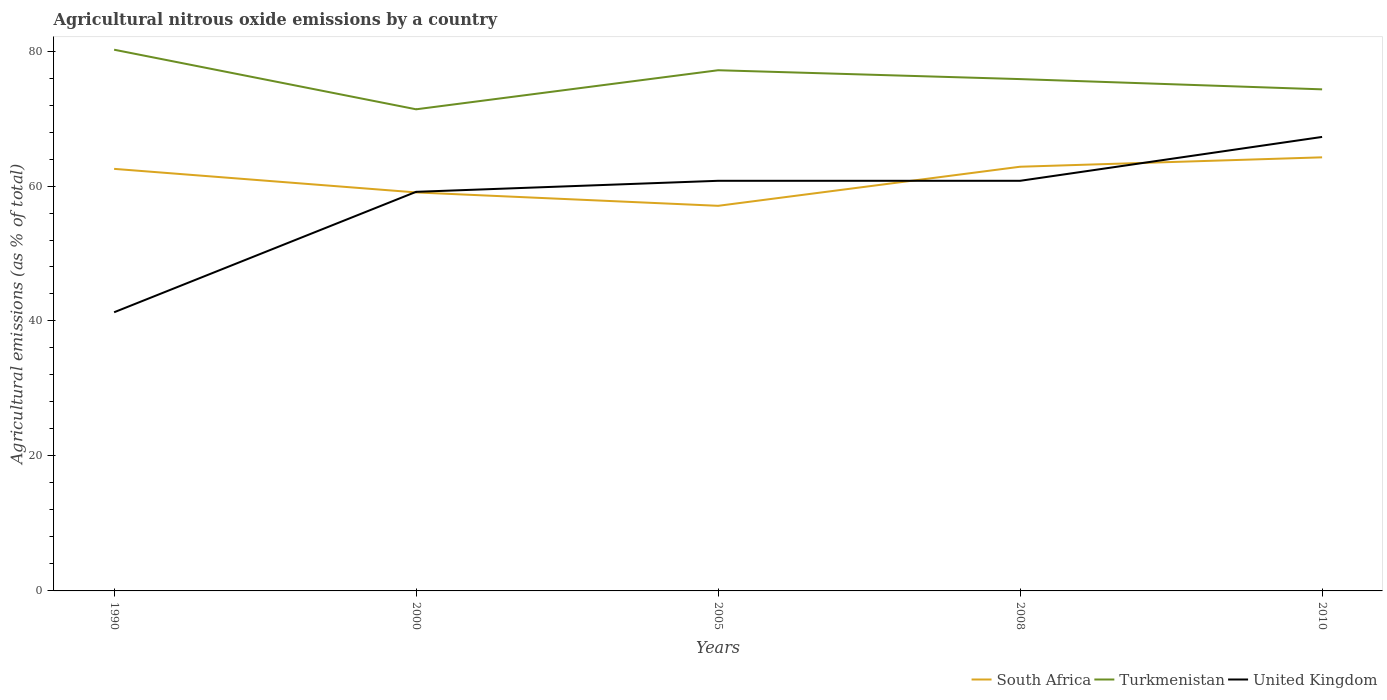Is the number of lines equal to the number of legend labels?
Provide a short and direct response. Yes. Across all years, what is the maximum amount of agricultural nitrous oxide emitted in Turkmenistan?
Offer a very short reply. 71.37. In which year was the amount of agricultural nitrous oxide emitted in South Africa maximum?
Provide a succinct answer. 2005. What is the total amount of agricultural nitrous oxide emitted in South Africa in the graph?
Your answer should be very brief. 1.98. What is the difference between the highest and the second highest amount of agricultural nitrous oxide emitted in United Kingdom?
Keep it short and to the point. 25.98. How many years are there in the graph?
Your response must be concise. 5. Where does the legend appear in the graph?
Give a very brief answer. Bottom right. What is the title of the graph?
Ensure brevity in your answer.  Agricultural nitrous oxide emissions by a country. What is the label or title of the X-axis?
Ensure brevity in your answer.  Years. What is the label or title of the Y-axis?
Ensure brevity in your answer.  Agricultural emissions (as % of total). What is the Agricultural emissions (as % of total) in South Africa in 1990?
Offer a very short reply. 62.54. What is the Agricultural emissions (as % of total) in Turkmenistan in 1990?
Your answer should be compact. 80.2. What is the Agricultural emissions (as % of total) in United Kingdom in 1990?
Your answer should be very brief. 41.29. What is the Agricultural emissions (as % of total) in South Africa in 2000?
Give a very brief answer. 59.05. What is the Agricultural emissions (as % of total) of Turkmenistan in 2000?
Your response must be concise. 71.37. What is the Agricultural emissions (as % of total) of United Kingdom in 2000?
Make the answer very short. 59.14. What is the Agricultural emissions (as % of total) in South Africa in 2005?
Keep it short and to the point. 57.07. What is the Agricultural emissions (as % of total) of Turkmenistan in 2005?
Give a very brief answer. 77.16. What is the Agricultural emissions (as % of total) of United Kingdom in 2005?
Your response must be concise. 60.77. What is the Agricultural emissions (as % of total) in South Africa in 2008?
Offer a very short reply. 62.86. What is the Agricultural emissions (as % of total) in Turkmenistan in 2008?
Provide a succinct answer. 75.84. What is the Agricultural emissions (as % of total) of United Kingdom in 2008?
Your answer should be very brief. 60.77. What is the Agricultural emissions (as % of total) in South Africa in 2010?
Offer a terse response. 64.25. What is the Agricultural emissions (as % of total) in Turkmenistan in 2010?
Offer a terse response. 74.32. What is the Agricultural emissions (as % of total) in United Kingdom in 2010?
Give a very brief answer. 67.27. Across all years, what is the maximum Agricultural emissions (as % of total) of South Africa?
Your response must be concise. 64.25. Across all years, what is the maximum Agricultural emissions (as % of total) in Turkmenistan?
Make the answer very short. 80.2. Across all years, what is the maximum Agricultural emissions (as % of total) of United Kingdom?
Make the answer very short. 67.27. Across all years, what is the minimum Agricultural emissions (as % of total) of South Africa?
Make the answer very short. 57.07. Across all years, what is the minimum Agricultural emissions (as % of total) in Turkmenistan?
Your response must be concise. 71.37. Across all years, what is the minimum Agricultural emissions (as % of total) in United Kingdom?
Make the answer very short. 41.29. What is the total Agricultural emissions (as % of total) of South Africa in the graph?
Give a very brief answer. 305.76. What is the total Agricultural emissions (as % of total) of Turkmenistan in the graph?
Provide a succinct answer. 378.89. What is the total Agricultural emissions (as % of total) in United Kingdom in the graph?
Provide a short and direct response. 289.25. What is the difference between the Agricultural emissions (as % of total) in South Africa in 1990 and that in 2000?
Your response must be concise. 3.49. What is the difference between the Agricultural emissions (as % of total) in Turkmenistan in 1990 and that in 2000?
Your answer should be compact. 8.83. What is the difference between the Agricultural emissions (as % of total) in United Kingdom in 1990 and that in 2000?
Offer a very short reply. -17.85. What is the difference between the Agricultural emissions (as % of total) of South Africa in 1990 and that in 2005?
Your answer should be compact. 5.48. What is the difference between the Agricultural emissions (as % of total) in Turkmenistan in 1990 and that in 2005?
Keep it short and to the point. 3.04. What is the difference between the Agricultural emissions (as % of total) of United Kingdom in 1990 and that in 2005?
Your answer should be very brief. -19.48. What is the difference between the Agricultural emissions (as % of total) of South Africa in 1990 and that in 2008?
Keep it short and to the point. -0.32. What is the difference between the Agricultural emissions (as % of total) of Turkmenistan in 1990 and that in 2008?
Offer a terse response. 4.36. What is the difference between the Agricultural emissions (as % of total) of United Kingdom in 1990 and that in 2008?
Provide a succinct answer. -19.48. What is the difference between the Agricultural emissions (as % of total) in South Africa in 1990 and that in 2010?
Offer a very short reply. -1.71. What is the difference between the Agricultural emissions (as % of total) of Turkmenistan in 1990 and that in 2010?
Offer a very short reply. 5.87. What is the difference between the Agricultural emissions (as % of total) in United Kingdom in 1990 and that in 2010?
Your answer should be compact. -25.98. What is the difference between the Agricultural emissions (as % of total) in South Africa in 2000 and that in 2005?
Offer a terse response. 1.98. What is the difference between the Agricultural emissions (as % of total) of Turkmenistan in 2000 and that in 2005?
Your answer should be compact. -5.79. What is the difference between the Agricultural emissions (as % of total) in United Kingdom in 2000 and that in 2005?
Offer a very short reply. -1.63. What is the difference between the Agricultural emissions (as % of total) in South Africa in 2000 and that in 2008?
Your response must be concise. -3.81. What is the difference between the Agricultural emissions (as % of total) of Turkmenistan in 2000 and that in 2008?
Provide a succinct answer. -4.48. What is the difference between the Agricultural emissions (as % of total) in United Kingdom in 2000 and that in 2008?
Your answer should be compact. -1.63. What is the difference between the Agricultural emissions (as % of total) in South Africa in 2000 and that in 2010?
Your response must be concise. -5.2. What is the difference between the Agricultural emissions (as % of total) of Turkmenistan in 2000 and that in 2010?
Provide a short and direct response. -2.96. What is the difference between the Agricultural emissions (as % of total) of United Kingdom in 2000 and that in 2010?
Give a very brief answer. -8.13. What is the difference between the Agricultural emissions (as % of total) of South Africa in 2005 and that in 2008?
Offer a very short reply. -5.79. What is the difference between the Agricultural emissions (as % of total) in Turkmenistan in 2005 and that in 2008?
Your response must be concise. 1.31. What is the difference between the Agricultural emissions (as % of total) of United Kingdom in 2005 and that in 2008?
Give a very brief answer. 0. What is the difference between the Agricultural emissions (as % of total) of South Africa in 2005 and that in 2010?
Ensure brevity in your answer.  -7.18. What is the difference between the Agricultural emissions (as % of total) of Turkmenistan in 2005 and that in 2010?
Provide a short and direct response. 2.83. What is the difference between the Agricultural emissions (as % of total) of United Kingdom in 2005 and that in 2010?
Your answer should be compact. -6.5. What is the difference between the Agricultural emissions (as % of total) of South Africa in 2008 and that in 2010?
Give a very brief answer. -1.39. What is the difference between the Agricultural emissions (as % of total) of Turkmenistan in 2008 and that in 2010?
Keep it short and to the point. 1.52. What is the difference between the Agricultural emissions (as % of total) of United Kingdom in 2008 and that in 2010?
Your answer should be compact. -6.5. What is the difference between the Agricultural emissions (as % of total) in South Africa in 1990 and the Agricultural emissions (as % of total) in Turkmenistan in 2000?
Ensure brevity in your answer.  -8.83. What is the difference between the Agricultural emissions (as % of total) of South Africa in 1990 and the Agricultural emissions (as % of total) of United Kingdom in 2000?
Provide a succinct answer. 3.4. What is the difference between the Agricultural emissions (as % of total) in Turkmenistan in 1990 and the Agricultural emissions (as % of total) in United Kingdom in 2000?
Offer a terse response. 21.06. What is the difference between the Agricultural emissions (as % of total) of South Africa in 1990 and the Agricultural emissions (as % of total) of Turkmenistan in 2005?
Provide a short and direct response. -14.61. What is the difference between the Agricultural emissions (as % of total) in South Africa in 1990 and the Agricultural emissions (as % of total) in United Kingdom in 2005?
Keep it short and to the point. 1.77. What is the difference between the Agricultural emissions (as % of total) of Turkmenistan in 1990 and the Agricultural emissions (as % of total) of United Kingdom in 2005?
Your response must be concise. 19.43. What is the difference between the Agricultural emissions (as % of total) of South Africa in 1990 and the Agricultural emissions (as % of total) of Turkmenistan in 2008?
Your response must be concise. -13.3. What is the difference between the Agricultural emissions (as % of total) of South Africa in 1990 and the Agricultural emissions (as % of total) of United Kingdom in 2008?
Ensure brevity in your answer.  1.77. What is the difference between the Agricultural emissions (as % of total) of Turkmenistan in 1990 and the Agricultural emissions (as % of total) of United Kingdom in 2008?
Your answer should be compact. 19.43. What is the difference between the Agricultural emissions (as % of total) of South Africa in 1990 and the Agricultural emissions (as % of total) of Turkmenistan in 2010?
Ensure brevity in your answer.  -11.78. What is the difference between the Agricultural emissions (as % of total) in South Africa in 1990 and the Agricultural emissions (as % of total) in United Kingdom in 2010?
Provide a succinct answer. -4.73. What is the difference between the Agricultural emissions (as % of total) in Turkmenistan in 1990 and the Agricultural emissions (as % of total) in United Kingdom in 2010?
Provide a short and direct response. 12.93. What is the difference between the Agricultural emissions (as % of total) in South Africa in 2000 and the Agricultural emissions (as % of total) in Turkmenistan in 2005?
Your answer should be compact. -18.11. What is the difference between the Agricultural emissions (as % of total) of South Africa in 2000 and the Agricultural emissions (as % of total) of United Kingdom in 2005?
Keep it short and to the point. -1.72. What is the difference between the Agricultural emissions (as % of total) in Turkmenistan in 2000 and the Agricultural emissions (as % of total) in United Kingdom in 2005?
Provide a succinct answer. 10.59. What is the difference between the Agricultural emissions (as % of total) of South Africa in 2000 and the Agricultural emissions (as % of total) of Turkmenistan in 2008?
Your response must be concise. -16.79. What is the difference between the Agricultural emissions (as % of total) of South Africa in 2000 and the Agricultural emissions (as % of total) of United Kingdom in 2008?
Ensure brevity in your answer.  -1.72. What is the difference between the Agricultural emissions (as % of total) of Turkmenistan in 2000 and the Agricultural emissions (as % of total) of United Kingdom in 2008?
Make the answer very short. 10.6. What is the difference between the Agricultural emissions (as % of total) of South Africa in 2000 and the Agricultural emissions (as % of total) of Turkmenistan in 2010?
Make the answer very short. -15.27. What is the difference between the Agricultural emissions (as % of total) in South Africa in 2000 and the Agricultural emissions (as % of total) in United Kingdom in 2010?
Provide a short and direct response. -8.22. What is the difference between the Agricultural emissions (as % of total) of Turkmenistan in 2000 and the Agricultural emissions (as % of total) of United Kingdom in 2010?
Keep it short and to the point. 4.1. What is the difference between the Agricultural emissions (as % of total) in South Africa in 2005 and the Agricultural emissions (as % of total) in Turkmenistan in 2008?
Make the answer very short. -18.78. What is the difference between the Agricultural emissions (as % of total) of South Africa in 2005 and the Agricultural emissions (as % of total) of United Kingdom in 2008?
Your answer should be compact. -3.71. What is the difference between the Agricultural emissions (as % of total) in Turkmenistan in 2005 and the Agricultural emissions (as % of total) in United Kingdom in 2008?
Keep it short and to the point. 16.38. What is the difference between the Agricultural emissions (as % of total) in South Africa in 2005 and the Agricultural emissions (as % of total) in Turkmenistan in 2010?
Provide a succinct answer. -17.26. What is the difference between the Agricultural emissions (as % of total) in South Africa in 2005 and the Agricultural emissions (as % of total) in United Kingdom in 2010?
Make the answer very short. -10.21. What is the difference between the Agricultural emissions (as % of total) in Turkmenistan in 2005 and the Agricultural emissions (as % of total) in United Kingdom in 2010?
Make the answer very short. 9.88. What is the difference between the Agricultural emissions (as % of total) of South Africa in 2008 and the Agricultural emissions (as % of total) of Turkmenistan in 2010?
Offer a very short reply. -11.47. What is the difference between the Agricultural emissions (as % of total) in South Africa in 2008 and the Agricultural emissions (as % of total) in United Kingdom in 2010?
Offer a terse response. -4.42. What is the difference between the Agricultural emissions (as % of total) in Turkmenistan in 2008 and the Agricultural emissions (as % of total) in United Kingdom in 2010?
Make the answer very short. 8.57. What is the average Agricultural emissions (as % of total) in South Africa per year?
Give a very brief answer. 61.15. What is the average Agricultural emissions (as % of total) of Turkmenistan per year?
Your response must be concise. 75.78. What is the average Agricultural emissions (as % of total) in United Kingdom per year?
Offer a terse response. 57.85. In the year 1990, what is the difference between the Agricultural emissions (as % of total) of South Africa and Agricultural emissions (as % of total) of Turkmenistan?
Offer a terse response. -17.66. In the year 1990, what is the difference between the Agricultural emissions (as % of total) in South Africa and Agricultural emissions (as % of total) in United Kingdom?
Keep it short and to the point. 21.25. In the year 1990, what is the difference between the Agricultural emissions (as % of total) of Turkmenistan and Agricultural emissions (as % of total) of United Kingdom?
Your answer should be compact. 38.91. In the year 2000, what is the difference between the Agricultural emissions (as % of total) in South Africa and Agricultural emissions (as % of total) in Turkmenistan?
Provide a succinct answer. -12.32. In the year 2000, what is the difference between the Agricultural emissions (as % of total) in South Africa and Agricultural emissions (as % of total) in United Kingdom?
Offer a very short reply. -0.09. In the year 2000, what is the difference between the Agricultural emissions (as % of total) in Turkmenistan and Agricultural emissions (as % of total) in United Kingdom?
Offer a very short reply. 12.23. In the year 2005, what is the difference between the Agricultural emissions (as % of total) of South Africa and Agricultural emissions (as % of total) of Turkmenistan?
Provide a succinct answer. -20.09. In the year 2005, what is the difference between the Agricultural emissions (as % of total) in South Africa and Agricultural emissions (as % of total) in United Kingdom?
Your answer should be compact. -3.71. In the year 2005, what is the difference between the Agricultural emissions (as % of total) in Turkmenistan and Agricultural emissions (as % of total) in United Kingdom?
Keep it short and to the point. 16.38. In the year 2008, what is the difference between the Agricultural emissions (as % of total) in South Africa and Agricultural emissions (as % of total) in Turkmenistan?
Keep it short and to the point. -12.99. In the year 2008, what is the difference between the Agricultural emissions (as % of total) of South Africa and Agricultural emissions (as % of total) of United Kingdom?
Keep it short and to the point. 2.09. In the year 2008, what is the difference between the Agricultural emissions (as % of total) of Turkmenistan and Agricultural emissions (as % of total) of United Kingdom?
Keep it short and to the point. 15.07. In the year 2010, what is the difference between the Agricultural emissions (as % of total) of South Africa and Agricultural emissions (as % of total) of Turkmenistan?
Keep it short and to the point. -10.07. In the year 2010, what is the difference between the Agricultural emissions (as % of total) in South Africa and Agricultural emissions (as % of total) in United Kingdom?
Keep it short and to the point. -3.02. In the year 2010, what is the difference between the Agricultural emissions (as % of total) in Turkmenistan and Agricultural emissions (as % of total) in United Kingdom?
Offer a very short reply. 7.05. What is the ratio of the Agricultural emissions (as % of total) in South Africa in 1990 to that in 2000?
Give a very brief answer. 1.06. What is the ratio of the Agricultural emissions (as % of total) of Turkmenistan in 1990 to that in 2000?
Keep it short and to the point. 1.12. What is the ratio of the Agricultural emissions (as % of total) in United Kingdom in 1990 to that in 2000?
Give a very brief answer. 0.7. What is the ratio of the Agricultural emissions (as % of total) of South Africa in 1990 to that in 2005?
Give a very brief answer. 1.1. What is the ratio of the Agricultural emissions (as % of total) in Turkmenistan in 1990 to that in 2005?
Your answer should be very brief. 1.04. What is the ratio of the Agricultural emissions (as % of total) of United Kingdom in 1990 to that in 2005?
Ensure brevity in your answer.  0.68. What is the ratio of the Agricultural emissions (as % of total) of Turkmenistan in 1990 to that in 2008?
Make the answer very short. 1.06. What is the ratio of the Agricultural emissions (as % of total) of United Kingdom in 1990 to that in 2008?
Provide a short and direct response. 0.68. What is the ratio of the Agricultural emissions (as % of total) of South Africa in 1990 to that in 2010?
Make the answer very short. 0.97. What is the ratio of the Agricultural emissions (as % of total) in Turkmenistan in 1990 to that in 2010?
Your answer should be very brief. 1.08. What is the ratio of the Agricultural emissions (as % of total) of United Kingdom in 1990 to that in 2010?
Make the answer very short. 0.61. What is the ratio of the Agricultural emissions (as % of total) in South Africa in 2000 to that in 2005?
Your answer should be very brief. 1.03. What is the ratio of the Agricultural emissions (as % of total) of Turkmenistan in 2000 to that in 2005?
Your answer should be compact. 0.93. What is the ratio of the Agricultural emissions (as % of total) of United Kingdom in 2000 to that in 2005?
Provide a short and direct response. 0.97. What is the ratio of the Agricultural emissions (as % of total) of South Africa in 2000 to that in 2008?
Ensure brevity in your answer.  0.94. What is the ratio of the Agricultural emissions (as % of total) of Turkmenistan in 2000 to that in 2008?
Keep it short and to the point. 0.94. What is the ratio of the Agricultural emissions (as % of total) of United Kingdom in 2000 to that in 2008?
Your answer should be very brief. 0.97. What is the ratio of the Agricultural emissions (as % of total) of South Africa in 2000 to that in 2010?
Ensure brevity in your answer.  0.92. What is the ratio of the Agricultural emissions (as % of total) in Turkmenistan in 2000 to that in 2010?
Your response must be concise. 0.96. What is the ratio of the Agricultural emissions (as % of total) of United Kingdom in 2000 to that in 2010?
Your response must be concise. 0.88. What is the ratio of the Agricultural emissions (as % of total) in South Africa in 2005 to that in 2008?
Provide a short and direct response. 0.91. What is the ratio of the Agricultural emissions (as % of total) in Turkmenistan in 2005 to that in 2008?
Give a very brief answer. 1.02. What is the ratio of the Agricultural emissions (as % of total) of South Africa in 2005 to that in 2010?
Offer a terse response. 0.89. What is the ratio of the Agricultural emissions (as % of total) in Turkmenistan in 2005 to that in 2010?
Offer a terse response. 1.04. What is the ratio of the Agricultural emissions (as % of total) in United Kingdom in 2005 to that in 2010?
Your answer should be compact. 0.9. What is the ratio of the Agricultural emissions (as % of total) of South Africa in 2008 to that in 2010?
Offer a very short reply. 0.98. What is the ratio of the Agricultural emissions (as % of total) of Turkmenistan in 2008 to that in 2010?
Your response must be concise. 1.02. What is the ratio of the Agricultural emissions (as % of total) in United Kingdom in 2008 to that in 2010?
Provide a succinct answer. 0.9. What is the difference between the highest and the second highest Agricultural emissions (as % of total) of South Africa?
Provide a short and direct response. 1.39. What is the difference between the highest and the second highest Agricultural emissions (as % of total) in Turkmenistan?
Make the answer very short. 3.04. What is the difference between the highest and the second highest Agricultural emissions (as % of total) of United Kingdom?
Offer a very short reply. 6.5. What is the difference between the highest and the lowest Agricultural emissions (as % of total) of South Africa?
Provide a short and direct response. 7.18. What is the difference between the highest and the lowest Agricultural emissions (as % of total) of Turkmenistan?
Make the answer very short. 8.83. What is the difference between the highest and the lowest Agricultural emissions (as % of total) in United Kingdom?
Your answer should be compact. 25.98. 